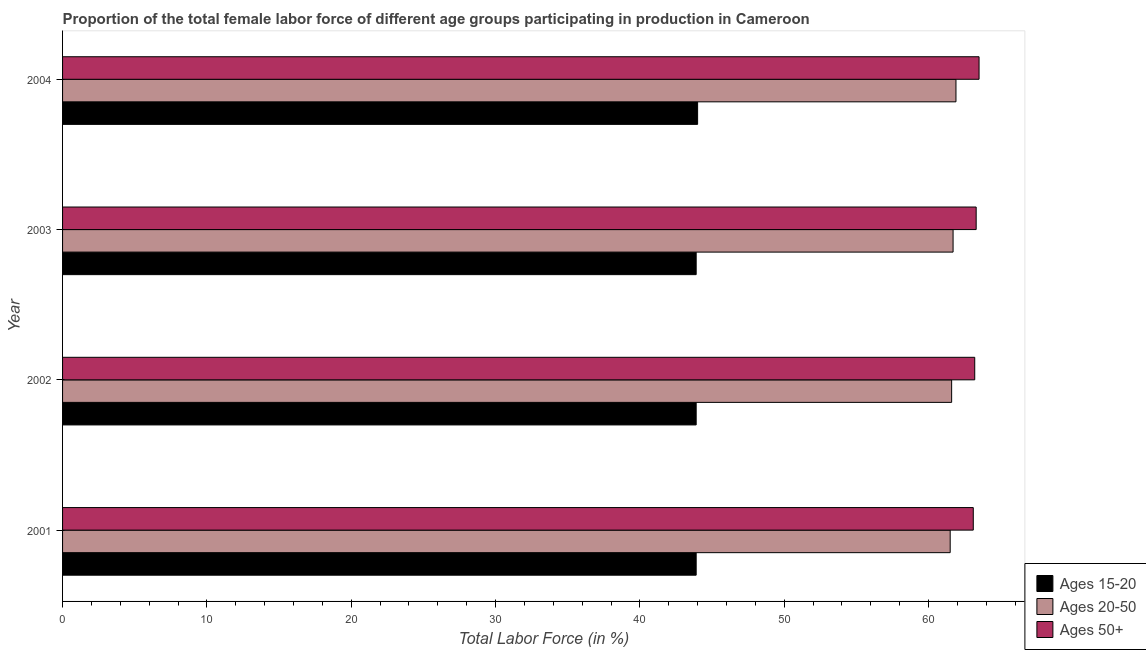How many groups of bars are there?
Your answer should be very brief. 4. Are the number of bars on each tick of the Y-axis equal?
Ensure brevity in your answer.  Yes. How many bars are there on the 1st tick from the top?
Ensure brevity in your answer.  3. What is the label of the 4th group of bars from the top?
Your answer should be very brief. 2001. What is the percentage of female labor force within the age group 15-20 in 2003?
Provide a short and direct response. 43.9. Across all years, what is the maximum percentage of female labor force within the age group 20-50?
Make the answer very short. 61.9. Across all years, what is the minimum percentage of female labor force within the age group 20-50?
Ensure brevity in your answer.  61.5. What is the total percentage of female labor force within the age group 20-50 in the graph?
Your answer should be very brief. 246.7. What is the difference between the percentage of female labor force within the age group 20-50 in 2001 and the percentage of female labor force within the age group 15-20 in 2003?
Your answer should be compact. 17.6. What is the average percentage of female labor force above age 50 per year?
Give a very brief answer. 63.27. In how many years, is the percentage of female labor force within the age group 20-50 greater than 10 %?
Provide a short and direct response. 4. Is the percentage of female labor force within the age group 20-50 in 2002 less than that in 2003?
Give a very brief answer. Yes. Is the difference between the percentage of female labor force above age 50 in 2001 and 2003 greater than the difference between the percentage of female labor force within the age group 20-50 in 2001 and 2003?
Give a very brief answer. Yes. What is the difference between the highest and the second highest percentage of female labor force above age 50?
Your answer should be very brief. 0.2. What is the difference between the highest and the lowest percentage of female labor force above age 50?
Keep it short and to the point. 0.4. Is the sum of the percentage of female labor force within the age group 20-50 in 2001 and 2002 greater than the maximum percentage of female labor force within the age group 15-20 across all years?
Offer a very short reply. Yes. What does the 2nd bar from the top in 2004 represents?
Give a very brief answer. Ages 20-50. What does the 3rd bar from the bottom in 2003 represents?
Offer a very short reply. Ages 50+. Is it the case that in every year, the sum of the percentage of female labor force within the age group 15-20 and percentage of female labor force within the age group 20-50 is greater than the percentage of female labor force above age 50?
Your answer should be very brief. Yes. How many bars are there?
Give a very brief answer. 12. How many years are there in the graph?
Your answer should be compact. 4. Does the graph contain any zero values?
Offer a very short reply. No. Does the graph contain grids?
Provide a succinct answer. No. What is the title of the graph?
Your response must be concise. Proportion of the total female labor force of different age groups participating in production in Cameroon. Does "Communicable diseases" appear as one of the legend labels in the graph?
Provide a short and direct response. No. What is the label or title of the X-axis?
Your response must be concise. Total Labor Force (in %). What is the label or title of the Y-axis?
Your answer should be very brief. Year. What is the Total Labor Force (in %) in Ages 15-20 in 2001?
Offer a very short reply. 43.9. What is the Total Labor Force (in %) in Ages 20-50 in 2001?
Ensure brevity in your answer.  61.5. What is the Total Labor Force (in %) in Ages 50+ in 2001?
Offer a terse response. 63.1. What is the Total Labor Force (in %) in Ages 15-20 in 2002?
Give a very brief answer. 43.9. What is the Total Labor Force (in %) of Ages 20-50 in 2002?
Make the answer very short. 61.6. What is the Total Labor Force (in %) in Ages 50+ in 2002?
Keep it short and to the point. 63.2. What is the Total Labor Force (in %) in Ages 15-20 in 2003?
Offer a terse response. 43.9. What is the Total Labor Force (in %) in Ages 20-50 in 2003?
Your answer should be compact. 61.7. What is the Total Labor Force (in %) in Ages 50+ in 2003?
Offer a terse response. 63.3. What is the Total Labor Force (in %) of Ages 15-20 in 2004?
Make the answer very short. 44. What is the Total Labor Force (in %) of Ages 20-50 in 2004?
Give a very brief answer. 61.9. What is the Total Labor Force (in %) of Ages 50+ in 2004?
Provide a succinct answer. 63.5. Across all years, what is the maximum Total Labor Force (in %) of Ages 20-50?
Keep it short and to the point. 61.9. Across all years, what is the maximum Total Labor Force (in %) in Ages 50+?
Provide a succinct answer. 63.5. Across all years, what is the minimum Total Labor Force (in %) in Ages 15-20?
Your answer should be very brief. 43.9. Across all years, what is the minimum Total Labor Force (in %) of Ages 20-50?
Make the answer very short. 61.5. Across all years, what is the minimum Total Labor Force (in %) in Ages 50+?
Keep it short and to the point. 63.1. What is the total Total Labor Force (in %) of Ages 15-20 in the graph?
Ensure brevity in your answer.  175.7. What is the total Total Labor Force (in %) in Ages 20-50 in the graph?
Your response must be concise. 246.7. What is the total Total Labor Force (in %) in Ages 50+ in the graph?
Provide a succinct answer. 253.1. What is the difference between the Total Labor Force (in %) of Ages 15-20 in 2001 and that in 2002?
Ensure brevity in your answer.  0. What is the difference between the Total Labor Force (in %) in Ages 50+ in 2001 and that in 2002?
Offer a very short reply. -0.1. What is the difference between the Total Labor Force (in %) of Ages 20-50 in 2001 and that in 2003?
Keep it short and to the point. -0.2. What is the difference between the Total Labor Force (in %) in Ages 50+ in 2001 and that in 2003?
Make the answer very short. -0.2. What is the difference between the Total Labor Force (in %) in Ages 15-20 in 2001 and that in 2004?
Your answer should be very brief. -0.1. What is the difference between the Total Labor Force (in %) in Ages 50+ in 2001 and that in 2004?
Ensure brevity in your answer.  -0.4. What is the difference between the Total Labor Force (in %) of Ages 50+ in 2002 and that in 2003?
Your answer should be compact. -0.1. What is the difference between the Total Labor Force (in %) of Ages 15-20 in 2002 and that in 2004?
Your response must be concise. -0.1. What is the difference between the Total Labor Force (in %) of Ages 15-20 in 2003 and that in 2004?
Provide a short and direct response. -0.1. What is the difference between the Total Labor Force (in %) in Ages 50+ in 2003 and that in 2004?
Give a very brief answer. -0.2. What is the difference between the Total Labor Force (in %) in Ages 15-20 in 2001 and the Total Labor Force (in %) in Ages 20-50 in 2002?
Offer a very short reply. -17.7. What is the difference between the Total Labor Force (in %) in Ages 15-20 in 2001 and the Total Labor Force (in %) in Ages 50+ in 2002?
Offer a terse response. -19.3. What is the difference between the Total Labor Force (in %) in Ages 20-50 in 2001 and the Total Labor Force (in %) in Ages 50+ in 2002?
Offer a very short reply. -1.7. What is the difference between the Total Labor Force (in %) in Ages 15-20 in 2001 and the Total Labor Force (in %) in Ages 20-50 in 2003?
Keep it short and to the point. -17.8. What is the difference between the Total Labor Force (in %) of Ages 15-20 in 2001 and the Total Labor Force (in %) of Ages 50+ in 2003?
Offer a terse response. -19.4. What is the difference between the Total Labor Force (in %) of Ages 20-50 in 2001 and the Total Labor Force (in %) of Ages 50+ in 2003?
Your answer should be very brief. -1.8. What is the difference between the Total Labor Force (in %) in Ages 15-20 in 2001 and the Total Labor Force (in %) in Ages 20-50 in 2004?
Your answer should be very brief. -18. What is the difference between the Total Labor Force (in %) in Ages 15-20 in 2001 and the Total Labor Force (in %) in Ages 50+ in 2004?
Ensure brevity in your answer.  -19.6. What is the difference between the Total Labor Force (in %) in Ages 20-50 in 2001 and the Total Labor Force (in %) in Ages 50+ in 2004?
Make the answer very short. -2. What is the difference between the Total Labor Force (in %) in Ages 15-20 in 2002 and the Total Labor Force (in %) in Ages 20-50 in 2003?
Offer a very short reply. -17.8. What is the difference between the Total Labor Force (in %) in Ages 15-20 in 2002 and the Total Labor Force (in %) in Ages 50+ in 2003?
Your answer should be compact. -19.4. What is the difference between the Total Labor Force (in %) of Ages 20-50 in 2002 and the Total Labor Force (in %) of Ages 50+ in 2003?
Ensure brevity in your answer.  -1.7. What is the difference between the Total Labor Force (in %) of Ages 15-20 in 2002 and the Total Labor Force (in %) of Ages 50+ in 2004?
Offer a terse response. -19.6. What is the difference between the Total Labor Force (in %) of Ages 15-20 in 2003 and the Total Labor Force (in %) of Ages 20-50 in 2004?
Give a very brief answer. -18. What is the difference between the Total Labor Force (in %) of Ages 15-20 in 2003 and the Total Labor Force (in %) of Ages 50+ in 2004?
Provide a short and direct response. -19.6. What is the difference between the Total Labor Force (in %) in Ages 20-50 in 2003 and the Total Labor Force (in %) in Ages 50+ in 2004?
Provide a succinct answer. -1.8. What is the average Total Labor Force (in %) in Ages 15-20 per year?
Provide a short and direct response. 43.92. What is the average Total Labor Force (in %) of Ages 20-50 per year?
Offer a terse response. 61.67. What is the average Total Labor Force (in %) in Ages 50+ per year?
Give a very brief answer. 63.27. In the year 2001, what is the difference between the Total Labor Force (in %) of Ages 15-20 and Total Labor Force (in %) of Ages 20-50?
Offer a terse response. -17.6. In the year 2001, what is the difference between the Total Labor Force (in %) in Ages 15-20 and Total Labor Force (in %) in Ages 50+?
Your answer should be compact. -19.2. In the year 2002, what is the difference between the Total Labor Force (in %) in Ages 15-20 and Total Labor Force (in %) in Ages 20-50?
Provide a succinct answer. -17.7. In the year 2002, what is the difference between the Total Labor Force (in %) of Ages 15-20 and Total Labor Force (in %) of Ages 50+?
Give a very brief answer. -19.3. In the year 2003, what is the difference between the Total Labor Force (in %) in Ages 15-20 and Total Labor Force (in %) in Ages 20-50?
Make the answer very short. -17.8. In the year 2003, what is the difference between the Total Labor Force (in %) in Ages 15-20 and Total Labor Force (in %) in Ages 50+?
Provide a succinct answer. -19.4. In the year 2004, what is the difference between the Total Labor Force (in %) in Ages 15-20 and Total Labor Force (in %) in Ages 20-50?
Keep it short and to the point. -17.9. In the year 2004, what is the difference between the Total Labor Force (in %) of Ages 15-20 and Total Labor Force (in %) of Ages 50+?
Provide a succinct answer. -19.5. In the year 2004, what is the difference between the Total Labor Force (in %) in Ages 20-50 and Total Labor Force (in %) in Ages 50+?
Provide a succinct answer. -1.6. What is the ratio of the Total Labor Force (in %) in Ages 15-20 in 2001 to that in 2002?
Provide a short and direct response. 1. What is the ratio of the Total Labor Force (in %) of Ages 20-50 in 2001 to that in 2002?
Make the answer very short. 1. What is the ratio of the Total Labor Force (in %) of Ages 15-20 in 2001 to that in 2003?
Ensure brevity in your answer.  1. What is the ratio of the Total Labor Force (in %) of Ages 50+ in 2001 to that in 2003?
Ensure brevity in your answer.  1. What is the ratio of the Total Labor Force (in %) of Ages 15-20 in 2001 to that in 2004?
Offer a terse response. 1. What is the ratio of the Total Labor Force (in %) of Ages 50+ in 2001 to that in 2004?
Offer a very short reply. 0.99. What is the ratio of the Total Labor Force (in %) of Ages 15-20 in 2002 to that in 2003?
Make the answer very short. 1. What is the ratio of the Total Labor Force (in %) of Ages 20-50 in 2002 to that in 2004?
Provide a succinct answer. 1. What is the ratio of the Total Labor Force (in %) of Ages 15-20 in 2003 to that in 2004?
Keep it short and to the point. 1. What is the ratio of the Total Labor Force (in %) in Ages 20-50 in 2003 to that in 2004?
Provide a short and direct response. 1. What is the ratio of the Total Labor Force (in %) of Ages 50+ in 2003 to that in 2004?
Your answer should be very brief. 1. What is the difference between the highest and the second highest Total Labor Force (in %) in Ages 15-20?
Your response must be concise. 0.1. What is the difference between the highest and the second highest Total Labor Force (in %) in Ages 20-50?
Offer a terse response. 0.2. What is the difference between the highest and the lowest Total Labor Force (in %) in Ages 50+?
Provide a short and direct response. 0.4. 